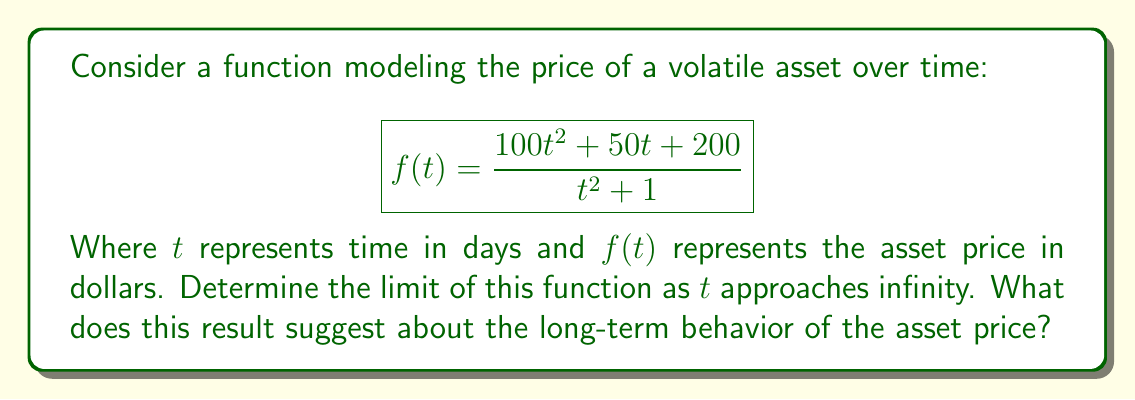Could you help me with this problem? To determine the limit of this function as $t$ approaches infinity, we can use the following steps:

1) First, let's examine the degrees of the numerator and denominator:
   - Numerator: $100t^2 + 50t + 200$ (degree 2)
   - Denominator: $t^2 + 1$ (degree 2)

2) When the degrees are equal, the limit will be the ratio of the leading coefficients. In this case:

   $$\lim_{t \to \infty} f(t) = \lim_{t \to \infty} \frac{100t^2 + 50t + 200}{t^2 + 1} = \frac{100}{1} = 100$$

3) We can verify this result using the following steps:
   
   $$\lim_{t \to \infty} f(t) = \lim_{t \to \infty} \frac{100t^2 + 50t + 200}{t^2 + 1}$$
   
   Divide both numerator and denominator by $t^2$:
   
   $$= \lim_{t \to \infty} \frac{100 + \frac{50}{t} + \frac{200}{t^2}}{1 + \frac{1}{t^2}}$$
   
   As $t$ approaches infinity, $\frac{1}{t}$ and $\frac{1}{t^2}$ approach 0:
   
   $$= \frac{100 + 0 + 0}{1 + 0} = 100$$

This result suggests that in the long term, the asset price tends to stabilize around $100. This information can be valuable for long-term investment planning and assessing the asset's potential for growth or stability.
Answer: The limit of the function as $t$ approaches infinity is 100. This suggests that the asset price tends to stabilize at $100 in the long term. 